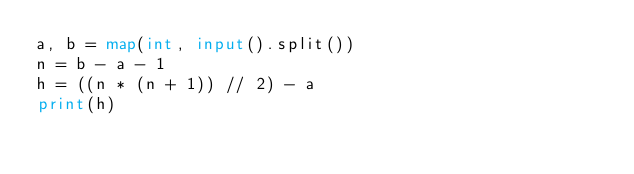Convert code to text. <code><loc_0><loc_0><loc_500><loc_500><_Python_>a, b = map(int, input().split())
n = b - a - 1
h = ((n * (n + 1)) // 2) - a
print(h)</code> 